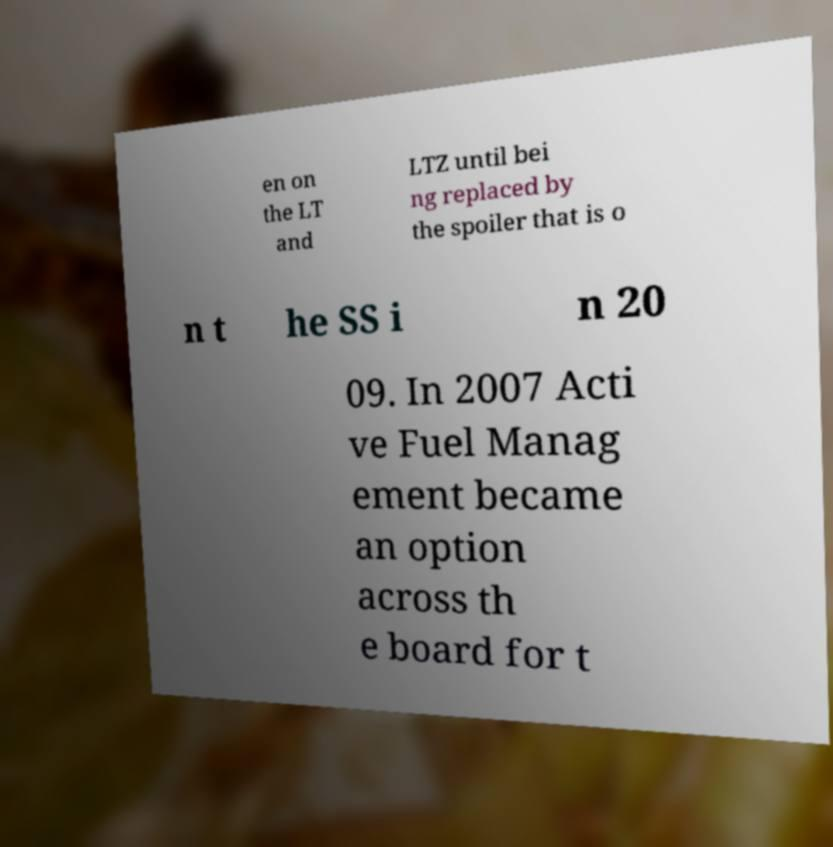There's text embedded in this image that I need extracted. Can you transcribe it verbatim? en on the LT and LTZ until bei ng replaced by the spoiler that is o n t he SS i n 20 09. In 2007 Acti ve Fuel Manag ement became an option across th e board for t 